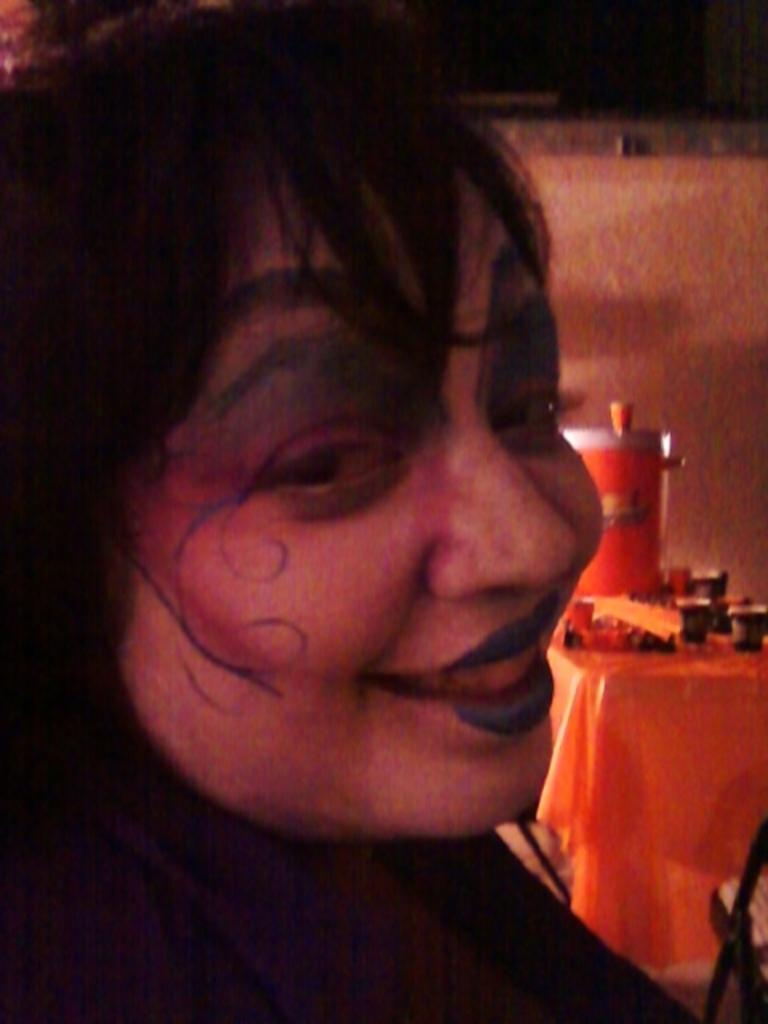Who is present in the image? There is a lady in the image. What is the lady doing in the image? The lady is smiling in the image. What can be seen on the right side of the image? There is a table on the right side of the image. What is placed on the table? There are things placed on the table. What type of furniture is visible in the image? There are chairs in the image. What is visible in the background of the image? There is a wall in the background of the image. What type of canvas is the lady holding in the image? There is no canvas present in the image. 